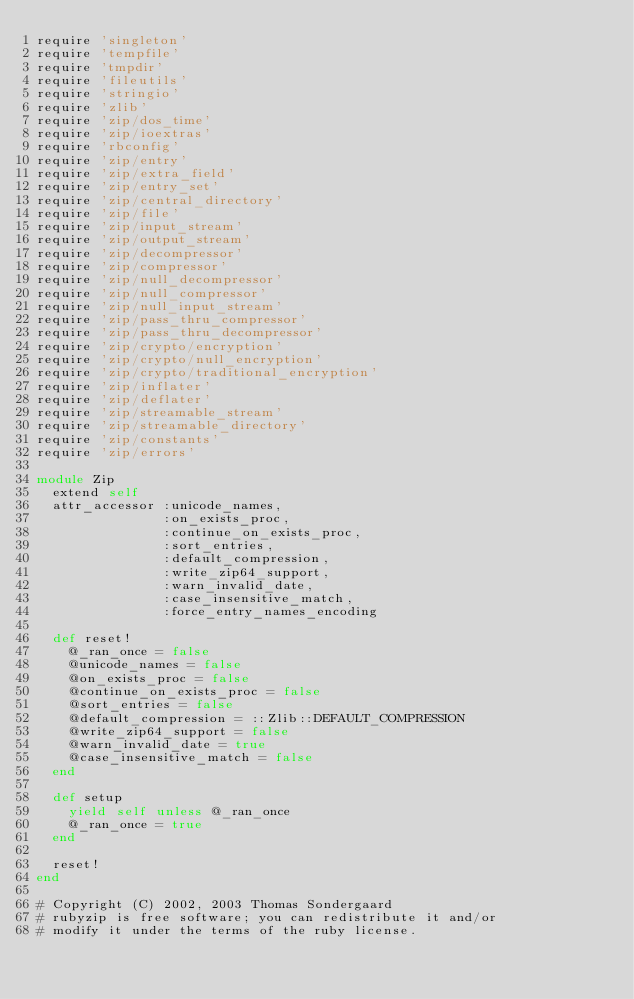Convert code to text. <code><loc_0><loc_0><loc_500><loc_500><_Ruby_>require 'singleton'
require 'tempfile'
require 'tmpdir'
require 'fileutils'
require 'stringio'
require 'zlib'
require 'zip/dos_time'
require 'zip/ioextras'
require 'rbconfig'
require 'zip/entry'
require 'zip/extra_field'
require 'zip/entry_set'
require 'zip/central_directory'
require 'zip/file'
require 'zip/input_stream'
require 'zip/output_stream'
require 'zip/decompressor'
require 'zip/compressor'
require 'zip/null_decompressor'
require 'zip/null_compressor'
require 'zip/null_input_stream'
require 'zip/pass_thru_compressor'
require 'zip/pass_thru_decompressor'
require 'zip/crypto/encryption'
require 'zip/crypto/null_encryption'
require 'zip/crypto/traditional_encryption'
require 'zip/inflater'
require 'zip/deflater'
require 'zip/streamable_stream'
require 'zip/streamable_directory'
require 'zip/constants'
require 'zip/errors'

module Zip
  extend self
  attr_accessor :unicode_names,
                :on_exists_proc,
                :continue_on_exists_proc,
                :sort_entries,
                :default_compression,
                :write_zip64_support,
                :warn_invalid_date,
                :case_insensitive_match,
                :force_entry_names_encoding

  def reset!
    @_ran_once = false
    @unicode_names = false
    @on_exists_proc = false
    @continue_on_exists_proc = false
    @sort_entries = false
    @default_compression = ::Zlib::DEFAULT_COMPRESSION
    @write_zip64_support = false
    @warn_invalid_date = true
    @case_insensitive_match = false
  end

  def setup
    yield self unless @_ran_once
    @_ran_once = true
  end

  reset!
end

# Copyright (C) 2002, 2003 Thomas Sondergaard
# rubyzip is free software; you can redistribute it and/or
# modify it under the terms of the ruby license.
</code> 